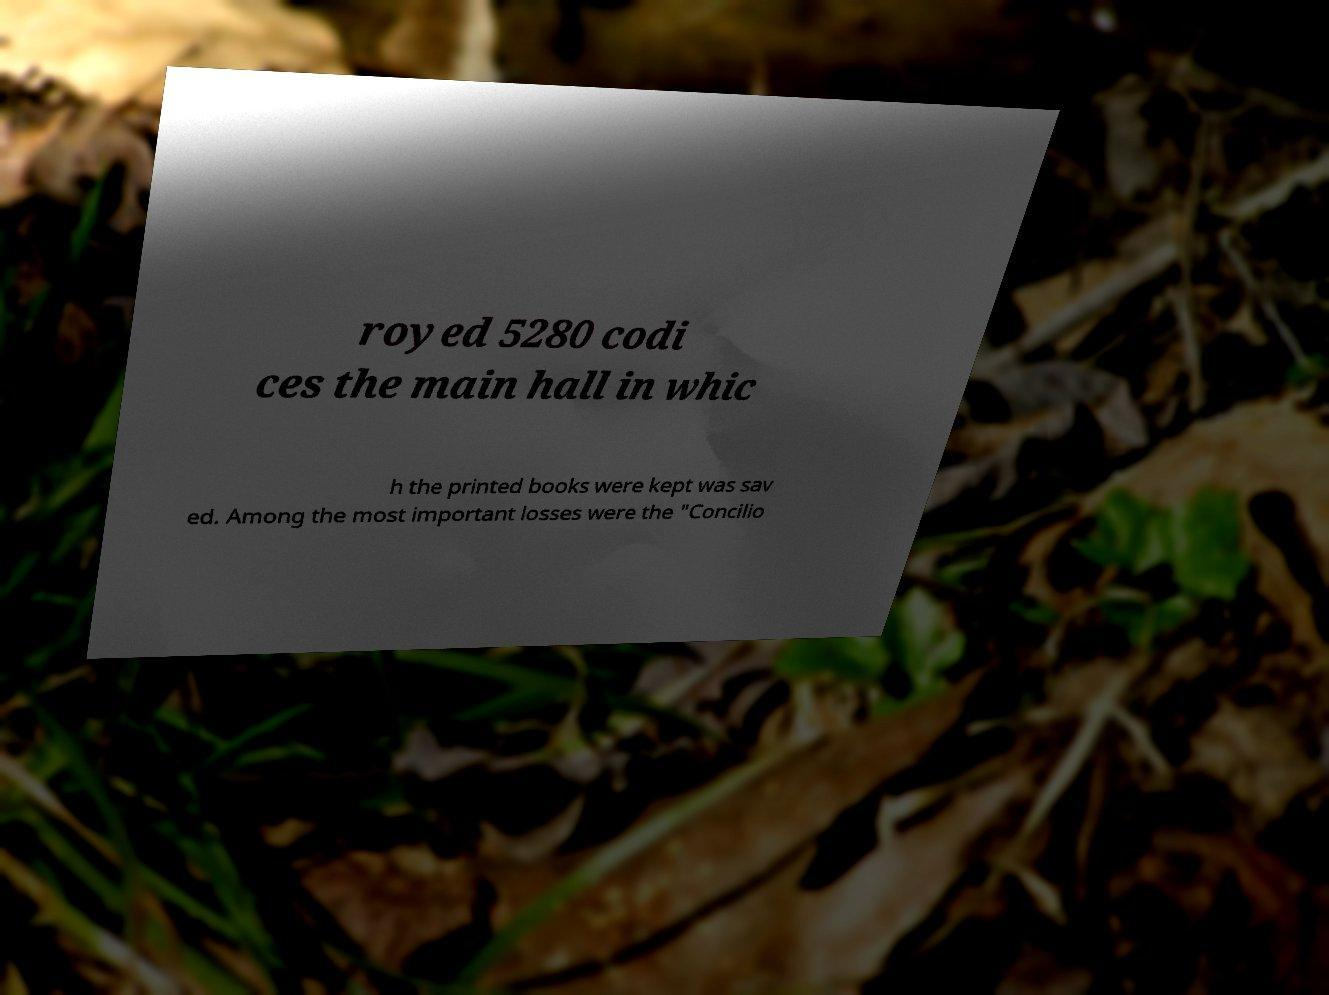Please read and relay the text visible in this image. What does it say? royed 5280 codi ces the main hall in whic h the printed books were kept was sav ed. Among the most important losses were the "Concilio 